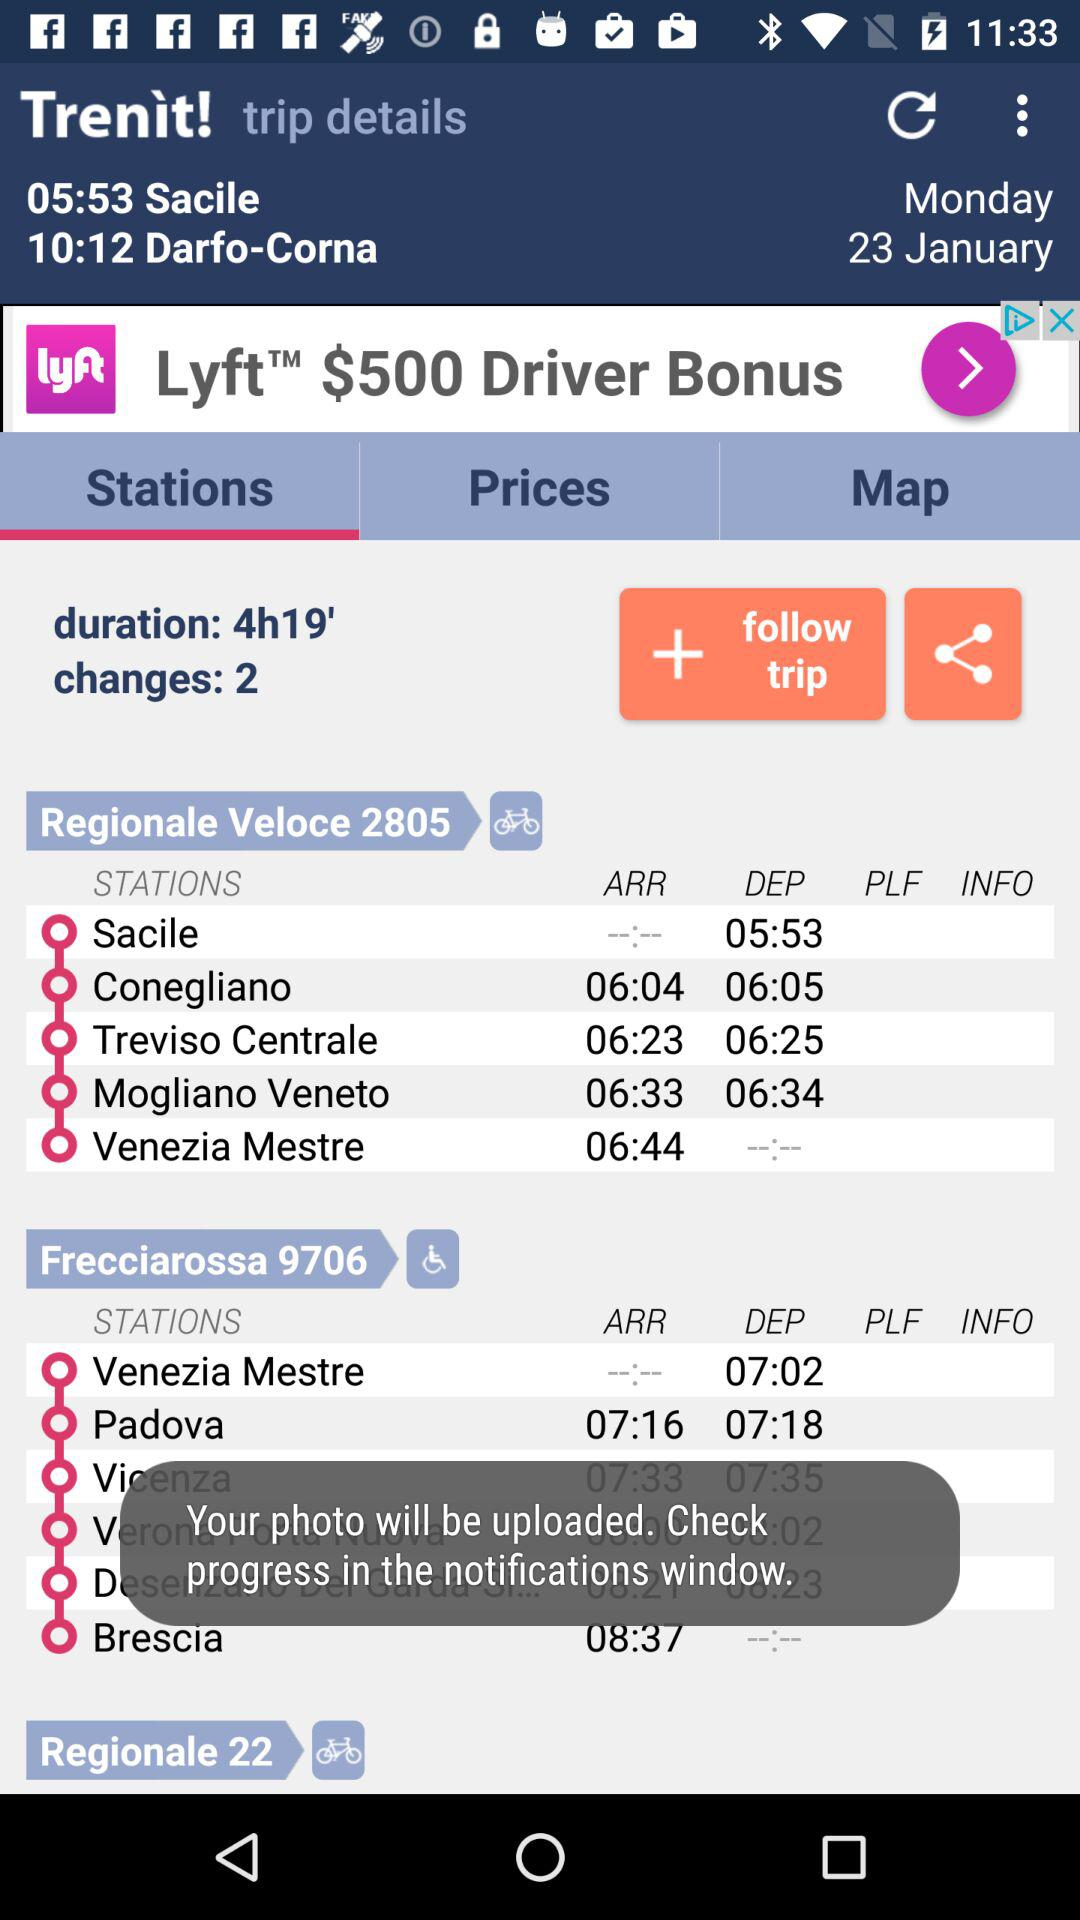Which tab is selected? The selected tab is "Stations". 